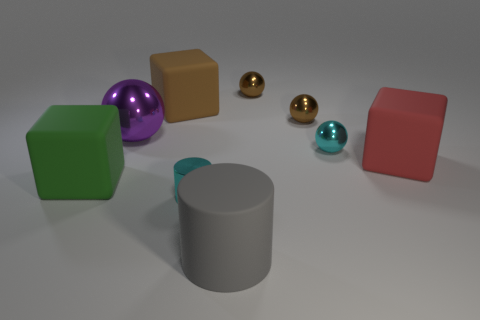How many cyan metal cylinders are there?
Provide a succinct answer. 1. There is a tiny cyan object on the left side of the brown ball behind the large cube behind the red block; what is it made of?
Offer a terse response. Metal. How many big objects are left of the block on the right side of the gray cylinder?
Offer a very short reply. 4. What is the color of the tiny thing that is the same shape as the large gray matte thing?
Keep it short and to the point. Cyan. Is the large gray object made of the same material as the large red block?
Make the answer very short. Yes. How many cylinders are rubber objects or large gray objects?
Make the answer very short. 1. There is a matte block behind the big matte cube that is to the right of the big matte cylinder that is in front of the brown matte block; how big is it?
Your answer should be compact. Large. There is a red matte thing that is the same shape as the large brown matte object; what size is it?
Ensure brevity in your answer.  Large. There is a large gray thing; what number of big matte blocks are behind it?
Give a very brief answer. 3. There is a rubber thing that is left of the large purple sphere; is its color the same as the large cylinder?
Keep it short and to the point. No. 